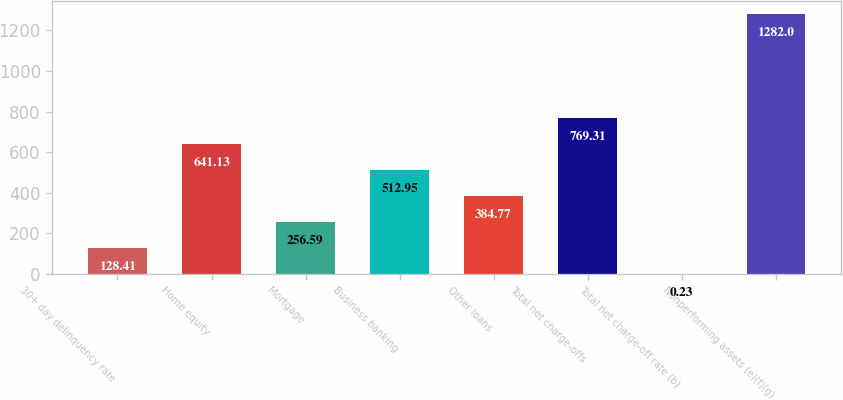Convert chart to OTSL. <chart><loc_0><loc_0><loc_500><loc_500><bar_chart><fcel>30+ day delinquency rate<fcel>Home equity<fcel>Mortgage<fcel>Business banking<fcel>Other loans<fcel>Total net charge-offs<fcel>Total net charge-off rate (b)<fcel>Nonperforming assets (e)(f)(g)<nl><fcel>128.41<fcel>641.13<fcel>256.59<fcel>512.95<fcel>384.77<fcel>769.31<fcel>0.23<fcel>1282<nl></chart> 